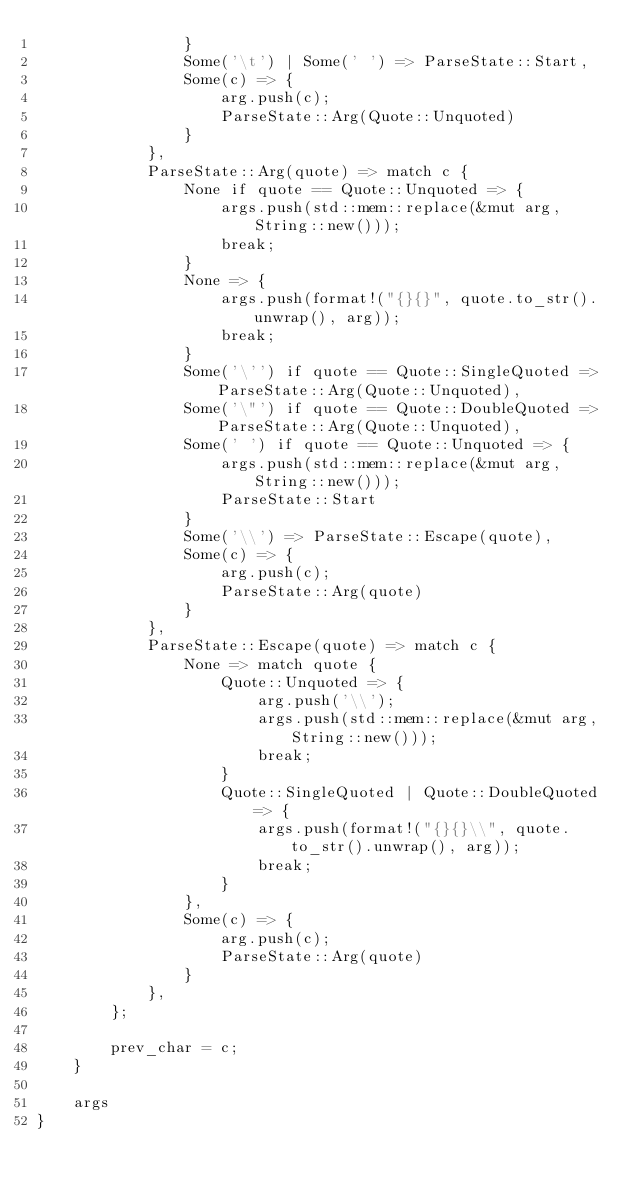Convert code to text. <code><loc_0><loc_0><loc_500><loc_500><_Rust_>                }
                Some('\t') | Some(' ') => ParseState::Start,
                Some(c) => {
                    arg.push(c);
                    ParseState::Arg(Quote::Unquoted)
                }
            },
            ParseState::Arg(quote) => match c {
                None if quote == Quote::Unquoted => {
                    args.push(std::mem::replace(&mut arg, String::new()));
                    break;
                }
                None => {
                    args.push(format!("{}{}", quote.to_str().unwrap(), arg));
                    break;
                }
                Some('\'') if quote == Quote::SingleQuoted => ParseState::Arg(Quote::Unquoted),
                Some('\"') if quote == Quote::DoubleQuoted => ParseState::Arg(Quote::Unquoted),
                Some(' ') if quote == Quote::Unquoted => {
                    args.push(std::mem::replace(&mut arg, String::new()));
                    ParseState::Start
                }
                Some('\\') => ParseState::Escape(quote),
                Some(c) => {
                    arg.push(c);
                    ParseState::Arg(quote)
                }
            },
            ParseState::Escape(quote) => match c {
                None => match quote {
                    Quote::Unquoted => {
                        arg.push('\\');
                        args.push(std::mem::replace(&mut arg, String::new()));
                        break;
                    }
                    Quote::SingleQuoted | Quote::DoubleQuoted => {
                        args.push(format!("{}{}\\", quote.to_str().unwrap(), arg));
                        break;
                    }
                },
                Some(c) => {
                    arg.push(c);
                    ParseState::Arg(quote)
                }
            },
        };

        prev_char = c;
    }

    args
}
</code> 